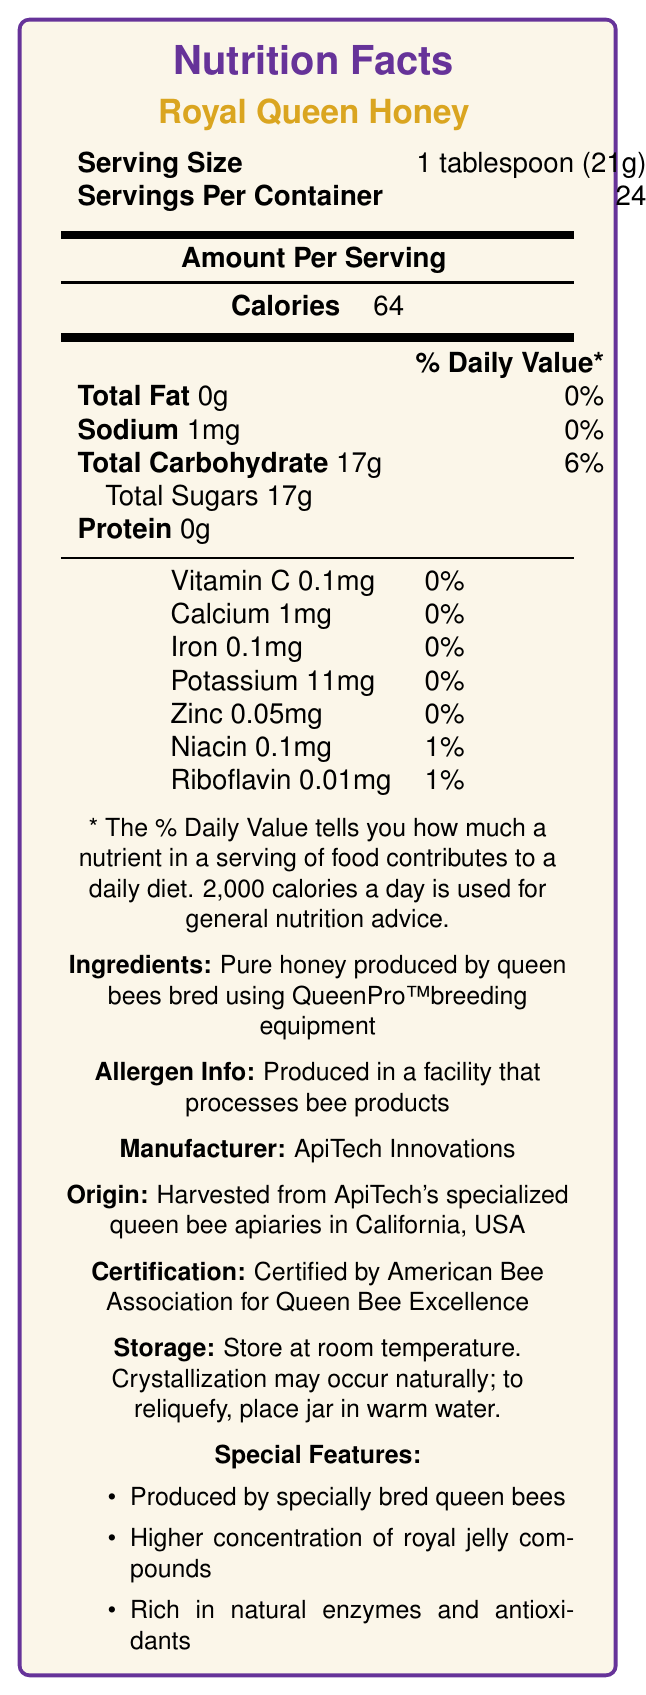What is the serving size of Royal Queen Honey? The document lists the serving size in the section titled "Serving Size" as "1 tablespoon (21g)".
Answer: 1 tablespoon (21g) How many servings are in each container of Royal Queen Honey? The section "Servings Per Container" indicates that there are 24 servings per container.
Answer: 24 How many calories are there per serving? The "Calories" section specifies that there are 64 calories per serving.
Answer: 64 What is the total carbohydrate content per serving? Under "Total Carbohydrate," the document states the amount as 17g per serving.
Answer: 17g Does Royal Queen Honey contain any protein? The "Protein" section states 0g, meaning it contains no protein.
Answer: No Which of the following nutrients has a daily value percentage listed as 0%? A. Niacin B. Zinc C. Riboflavin The nutrient Zinc is listed with 0% daily value, whereas Niacin and Riboflavin have 1% daily values.
Answer: B. Zinc How much Vitamin C is there per serving? The document shows that there is 0.1mg of Vitamin C per serving.
Answer: 0.1mg Is there any sodium in Royal Queen Honey? The document lists sodium as 1mg per serving, so there is a small amount of sodium.
Answer: Yes Which company manufactures Royal Queen Honey? The "Manufacturer" section lists ApiTech Innovations as the manufacturer.
Answer: ApiTech Innovations Is Royal Queen Honey produced in facilities that process bee products? The allergen information states that it is produced in a facility that processes bee products.
Answer: Yes List two special features of Royal Queen Honey. The "Special Features" section lists these features among others.
Answer: (1) Higher concentration of royal jelly compounds, (2) Rich in natural enzymes and antioxidants Is Royal Queen Honey certified by an organization, and if so, which one? The document states that the product is certified by the American Bee Association for Queen Bee Excellence.
Answer: Yes, Certified by American Bee Association for Queen Bee Excellence What is the total fat content per serving of Royal Queen Honey? The "Total Fat" section clearly lists the amount as 0g per serving.
Answer: 0g Where is the honey harvested? A. Florida, USA B. Texas, USA C. California, USA The "Origin" section specifies that the honey is harvested from ApiTech's specialized queen bee apiaries in California, USA.
Answer: C. California, USA Does Royal Queen Honey contain more sodium or protein per serving? The label shows 1mg of sodium and 0g of protein per serving, so it contains more sodium.
Answer: Sodium Summarize the main features of Royal Queen Honey. The summary covers most sections, including nutrition facts, ingredients, special features, manufacturing details, allergen information, and certifications.
Answer: Royal Queen Honey is a pure honey product with a serving size of 1 tablespoon (21g), providing 64 calories, 0g of total fat, 17g of carbohydrates, including 17g of sugars, and minimal amounts of sodium, proteins, vitamins, and minerals. It is produced by queen bees bred using specialized equipment, processed in facilities handling bee products, and certified for its excellence. The honey is rich in natural enzymes and antioxidants. Are there any artificial additives in Royal Queen Honey? The document doesn’t provide explicit information about artificial additives, only stating it contains "pure honey".
Answer: Not enough information What unique feature does QueenPro™ equipment provide for the production of Royal Queen Honey? The document mentions that the honey is produced by queen bees bred using QueenPro™ breeding equipment but does not specify what unique features this equipment provides.
Answer: Cannot be determined 